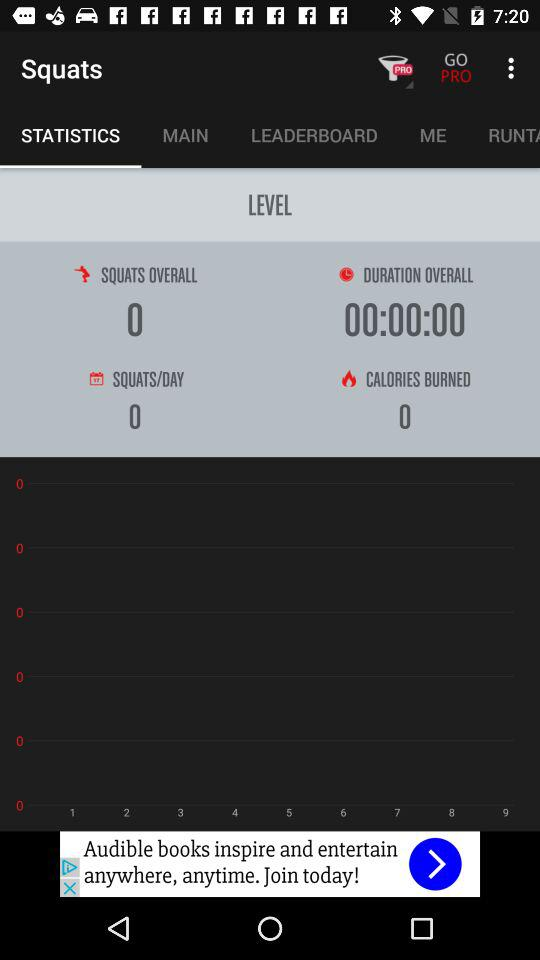What is the "Duration Overall"? The "Duration Overall" is 00:00:00. 